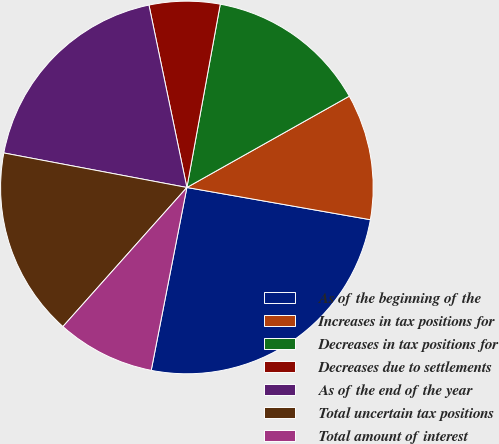Convert chart to OTSL. <chart><loc_0><loc_0><loc_500><loc_500><pie_chart><fcel>As of the beginning of the<fcel>Increases in tax positions for<fcel>Decreases in tax positions for<fcel>Decreases due to settlements<fcel>As of the end of the year<fcel>Total uncertain tax positions<fcel>Total amount of interest<nl><fcel>25.3%<fcel>10.92%<fcel>13.98%<fcel>6.13%<fcel>18.77%<fcel>16.38%<fcel>8.52%<nl></chart> 